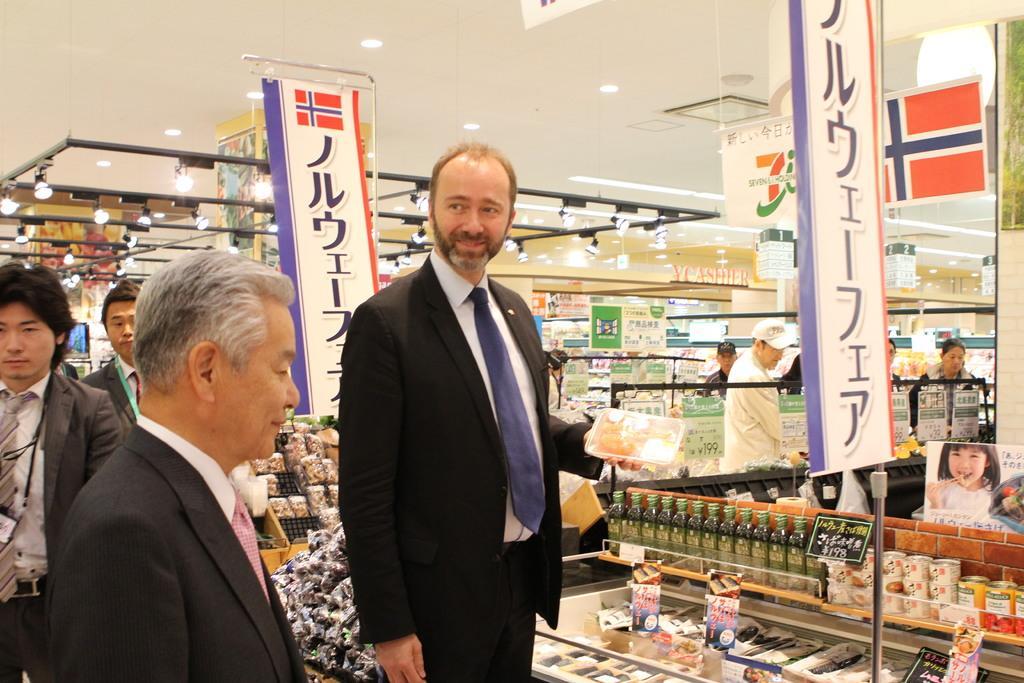Please provide a concise description of this image. In the middle a man is standing, he wore black color coat, trouser and a tie. It looks like a super market. 